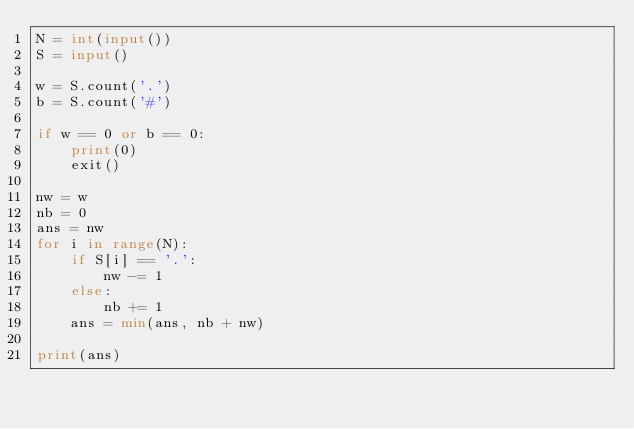<code> <loc_0><loc_0><loc_500><loc_500><_Python_>N = int(input())
S = input()

w = S.count('.')
b = S.count('#')

if w == 0 or b == 0:
    print(0)
    exit()

nw = w
nb = 0
ans = nw
for i in range(N):
    if S[i] == '.':
        nw -= 1
    else:
        nb += 1
    ans = min(ans, nb + nw)

print(ans)
</code> 